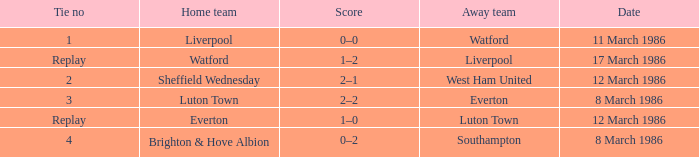In the sheffield wednesday's game, what was the score that led to a tie? 2.0. 